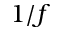<formula> <loc_0><loc_0><loc_500><loc_500>1 / f</formula> 